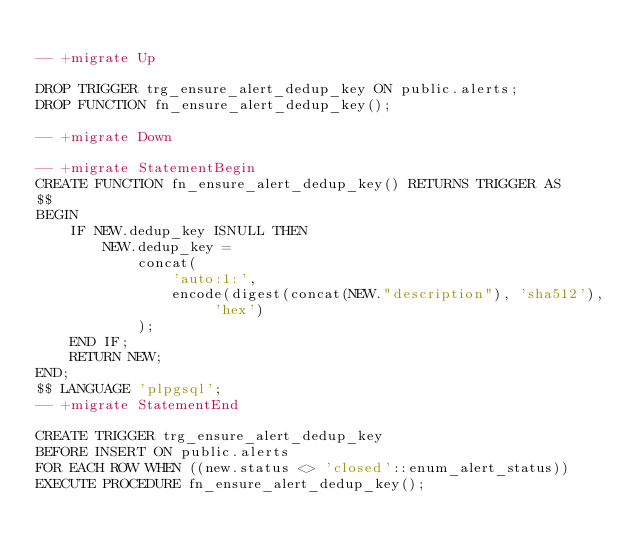Convert code to text. <code><loc_0><loc_0><loc_500><loc_500><_SQL_>
-- +migrate Up

DROP TRIGGER trg_ensure_alert_dedup_key ON public.alerts;
DROP FUNCTION fn_ensure_alert_dedup_key();

-- +migrate Down

-- +migrate StatementBegin
CREATE FUNCTION fn_ensure_alert_dedup_key() RETURNS TRIGGER AS
$$
BEGIN
    IF NEW.dedup_key ISNULL THEN
        NEW.dedup_key = 
            concat(
                'auto:1:',
                encode(digest(concat(NEW."description"), 'sha512'), 'hex')
            );
    END IF;
    RETURN NEW;
END;
$$ LANGUAGE 'plpgsql';
-- +migrate StatementEnd

CREATE TRIGGER trg_ensure_alert_dedup_key
BEFORE INSERT ON public.alerts
FOR EACH ROW WHEN ((new.status <> 'closed'::enum_alert_status))
EXECUTE PROCEDURE fn_ensure_alert_dedup_key();
</code> 